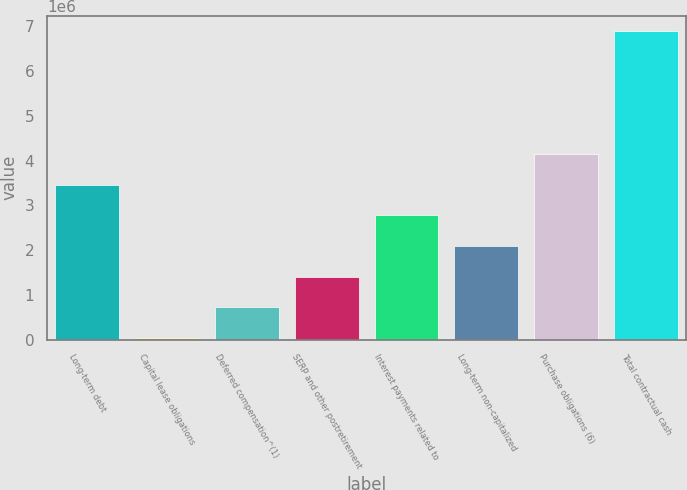Convert chart to OTSL. <chart><loc_0><loc_0><loc_500><loc_500><bar_chart><fcel>Long-term debt<fcel>Capital lease obligations<fcel>Deferred compensation^(1)<fcel>SERP and other postretirement<fcel>Interest payments related to<fcel>Long-term non-capitalized<fcel>Purchase obligations (6)<fcel>Total contractual cash<nl><fcel>3.46208e+06<fcel>36620<fcel>721713<fcel>1.40681e+06<fcel>2.77699e+06<fcel>2.0919e+06<fcel>4.14718e+06<fcel>6.88755e+06<nl></chart> 